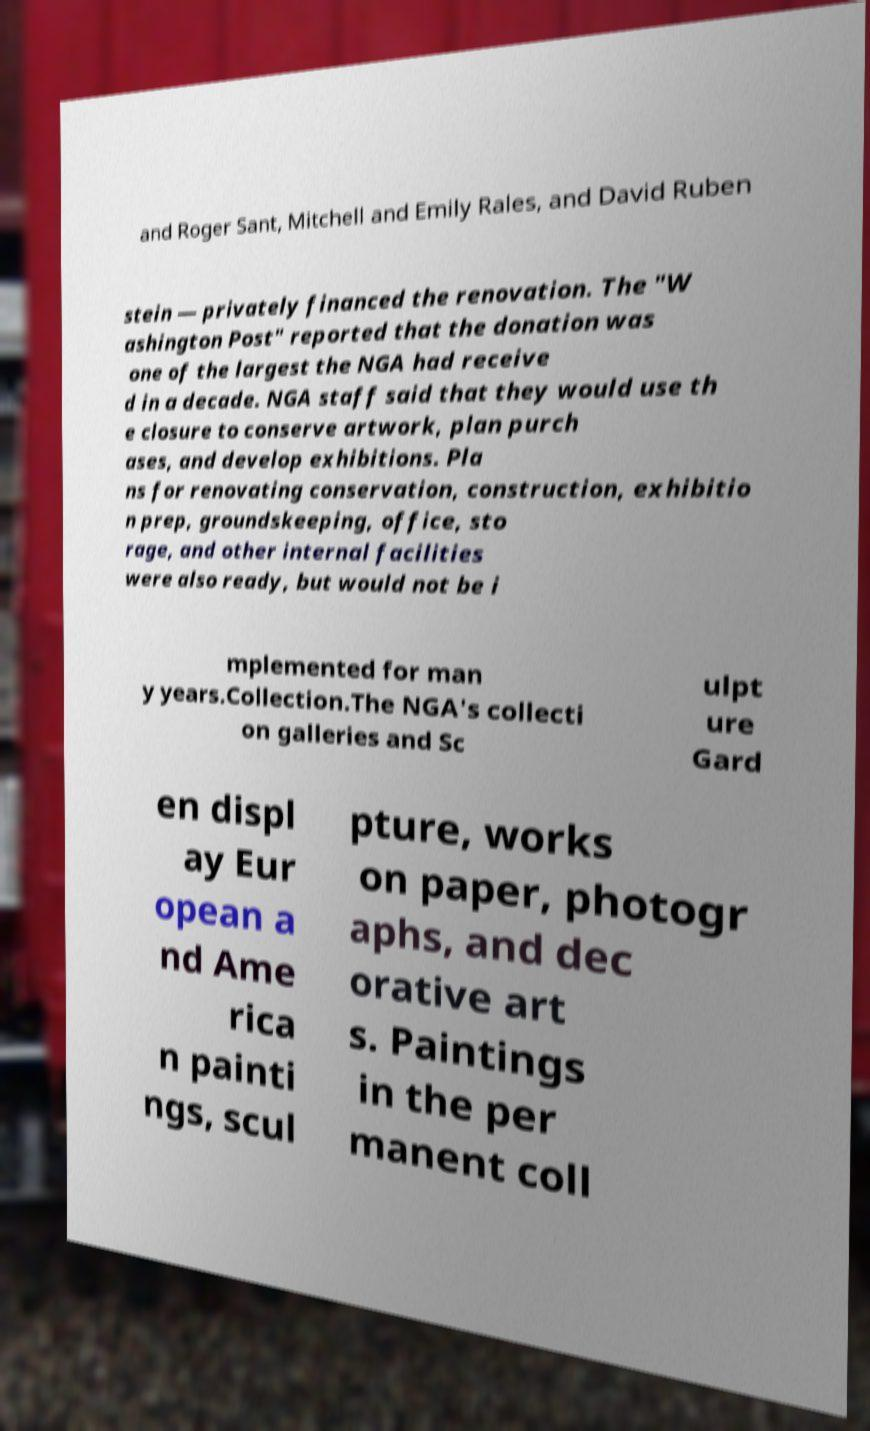For documentation purposes, I need the text within this image transcribed. Could you provide that? and Roger Sant, Mitchell and Emily Rales, and David Ruben stein — privately financed the renovation. The "W ashington Post" reported that the donation was one of the largest the NGA had receive d in a decade. NGA staff said that they would use th e closure to conserve artwork, plan purch ases, and develop exhibitions. Pla ns for renovating conservation, construction, exhibitio n prep, groundskeeping, office, sto rage, and other internal facilities were also ready, but would not be i mplemented for man y years.Collection.The NGA's collecti on galleries and Sc ulpt ure Gard en displ ay Eur opean a nd Ame rica n painti ngs, scul pture, works on paper, photogr aphs, and dec orative art s. Paintings in the per manent coll 